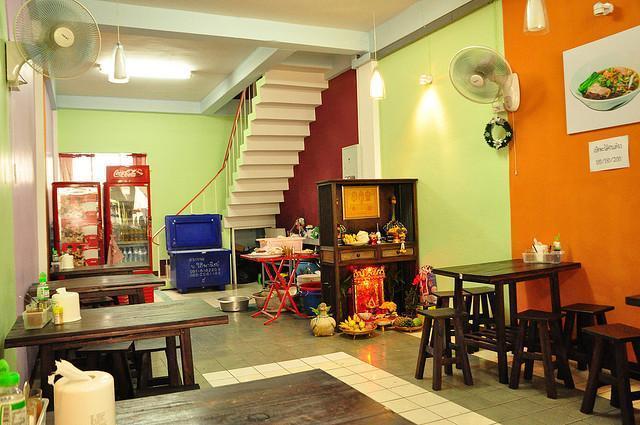How many dining tables are visible?
Give a very brief answer. 4. How many chairs are there?
Give a very brief answer. 3. How many refrigerators are there?
Give a very brief answer. 2. 